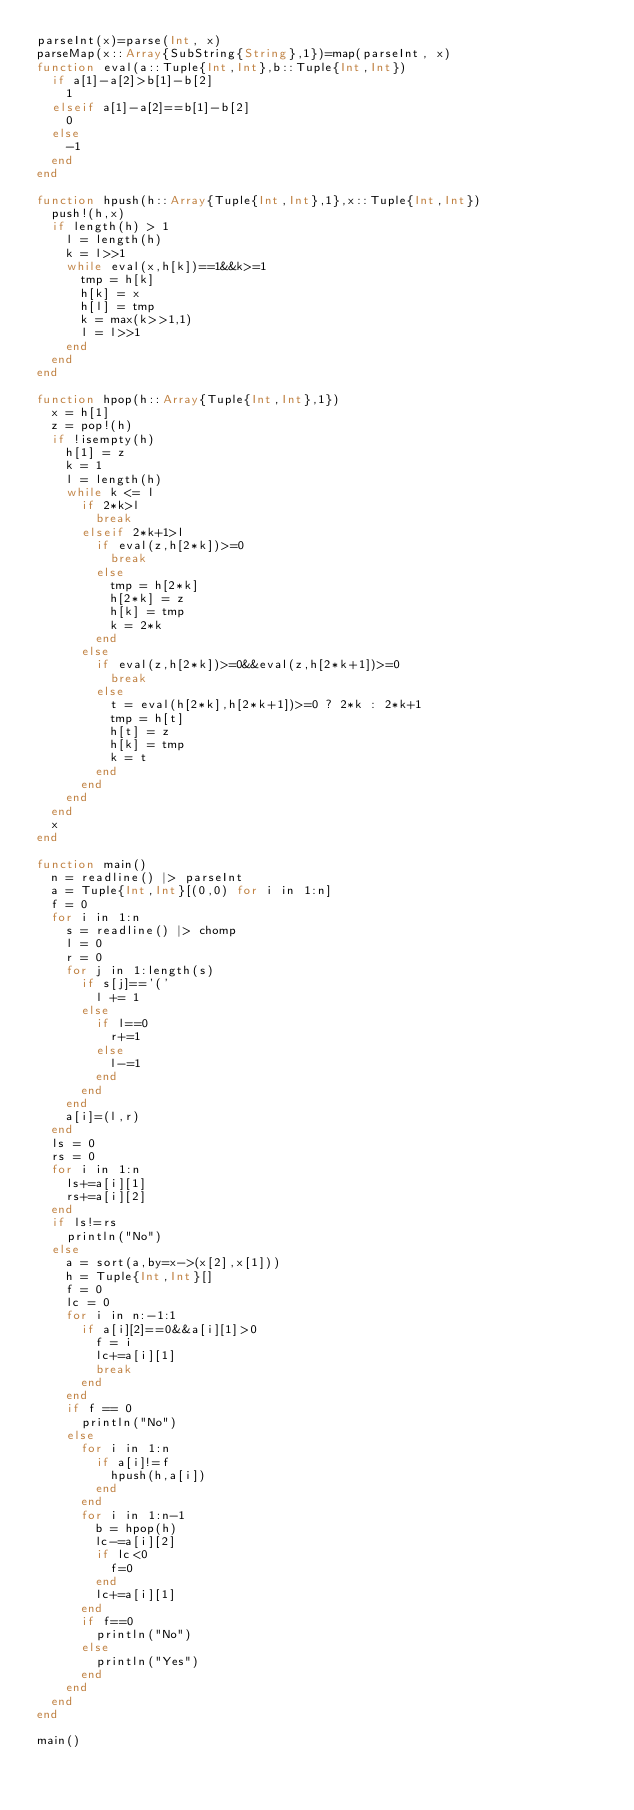<code> <loc_0><loc_0><loc_500><loc_500><_Julia_>parseInt(x)=parse(Int, x)
parseMap(x::Array{SubString{String},1})=map(parseInt, x)
function eval(a::Tuple{Int,Int},b::Tuple{Int,Int})
	if a[1]-a[2]>b[1]-b[2]
		1
	elseif a[1]-a[2]==b[1]-b[2]
		0
	else
		-1
	end
end

function hpush(h::Array{Tuple{Int,Int},1},x::Tuple{Int,Int})
	push!(h,x)
	if length(h) > 1
		l = length(h)
		k = l>>1
		while eval(x,h[k])==1&&k>=1
			tmp = h[k]
			h[k] = x
			h[l] = tmp
			k = max(k>>1,1)
			l = l>>1
		end
	end
end

function hpop(h::Array{Tuple{Int,Int},1})
	x = h[1]
	z = pop!(h)
	if !isempty(h)
		h[1] = z
		k = 1
		l = length(h)
		while k <= l
			if 2*k>l
				break
			elseif 2*k+1>l
				if eval(z,h[2*k])>=0
					break
				else
					tmp = h[2*k]
					h[2*k] = z
					h[k] = tmp
					k = 2*k
				end
			else
				if eval(z,h[2*k])>=0&&eval(z,h[2*k+1])>=0
					break
				else
					t = eval(h[2*k],h[2*k+1])>=0 ? 2*k : 2*k+1
					tmp = h[t]
					h[t] = z
					h[k] = tmp
					k = t
				end
			end
		end
	end
	x
end

function main()
	n = readline() |> parseInt
	a = Tuple{Int,Int}[(0,0) for i in 1:n]
	f = 0
	for i in 1:n
		s = readline() |> chomp
		l = 0
		r = 0
		for j in 1:length(s)
			if s[j]=='('
				l += 1
			else
				if l==0
					r+=1
				else
					l-=1
				end
			end
		end
		a[i]=(l,r)
	end
	ls = 0
	rs = 0
	for i in 1:n
		ls+=a[i][1]
		rs+=a[i][2]
	end
	if ls!=rs
		println("No")
	else
		a = sort(a,by=x->(x[2],x[1]))
		h = Tuple{Int,Int}[]
		f = 0
		lc = 0
		for i in n:-1:1
			if a[i][2]==0&&a[i][1]>0
				f = i
				lc+=a[i][1]
				break
			end
		end
		if f == 0
			println("No")
		else
			for i in 1:n
				if a[i]!=f
					hpush(h,a[i])
				end
			end
			for i in 1:n-1
				b = hpop(h)
				lc-=a[i][2]
				if lc<0
					f=0
				end
				lc+=a[i][1]
			end
			if f==0
				println("No")
			else
				println("Yes")
			end
		end
	end
end

main()</code> 